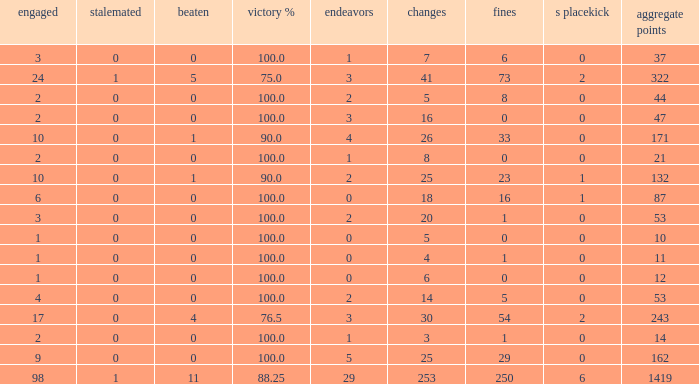Can you give me this table as a dict? {'header': ['engaged', 'stalemated', 'beaten', 'victory %', 'endeavors', 'changes', 'fines', 's placekick', 'aggregate points'], 'rows': [['3', '0', '0', '100.0', '1', '7', '6', '0', '37'], ['24', '1', '5', '75.0', '3', '41', '73', '2', '322'], ['2', '0', '0', '100.0', '2', '5', '8', '0', '44'], ['2', '0', '0', '100.0', '3', '16', '0', '0', '47'], ['10', '0', '1', '90.0', '4', '26', '33', '0', '171'], ['2', '0', '0', '100.0', '1', '8', '0', '0', '21'], ['10', '0', '1', '90.0', '2', '25', '23', '1', '132'], ['6', '0', '0', '100.0', '0', '18', '16', '1', '87'], ['3', '0', '0', '100.0', '2', '20', '1', '0', '53'], ['1', '0', '0', '100.0', '0', '5', '0', '0', '10'], ['1', '0', '0', '100.0', '0', '4', '1', '0', '11'], ['1', '0', '0', '100.0', '0', '6', '0', '0', '12'], ['4', '0', '0', '100.0', '2', '14', '5', '0', '53'], ['17', '0', '4', '76.5', '3', '30', '54', '2', '243'], ['2', '0', '0', '100.0', '1', '3', '1', '0', '14'], ['9', '0', '0', '100.0', '5', '25', '29', '0', '162'], ['98', '1', '11', '88.25', '29', '253', '250', '6', '1419']]} What is the least number of penalties he got when his point total was over 1419 in more than 98 games? None. 